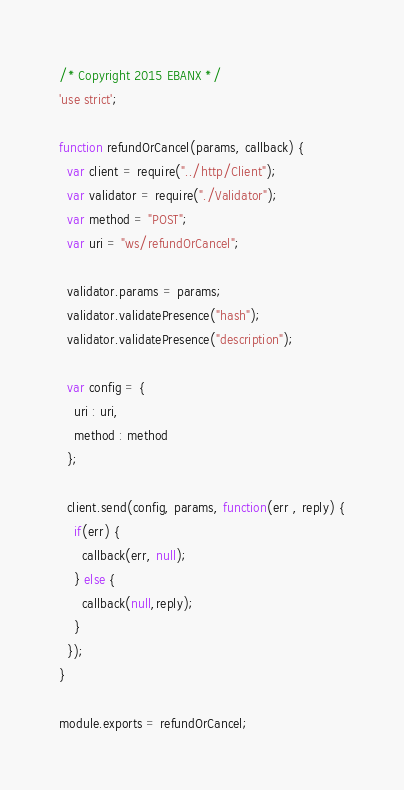<code> <loc_0><loc_0><loc_500><loc_500><_JavaScript_>/* Copyright 2015 EBANX */
'use strict';

function refundOrCancel(params, callback) {
  var client = require("../http/Client");
  var validator = require("./Validator");
  var method = "POST";
  var uri = "ws/refundOrCancel";

  validator.params = params;
  validator.validatePresence("hash");
  validator.validatePresence("description");
  
  var config = {
    uri : uri,
    method : method
  };

  client.send(config, params, function(err , reply) {
    if(err) {
      callback(err, null);
    } else {
      callback(null,reply);
    }
  });
}

module.exports = refundOrCancel;</code> 